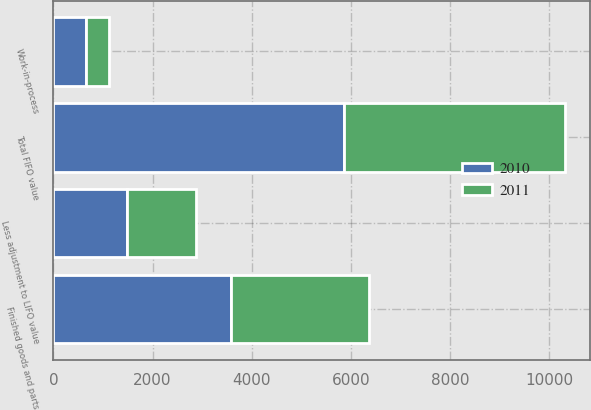Convert chart to OTSL. <chart><loc_0><loc_0><loc_500><loc_500><stacked_bar_chart><ecel><fcel>Work-in-process<fcel>Finished goods and parts<fcel>Total FIFO value<fcel>Less adjustment to LIFO value<nl><fcel>2010<fcel>647<fcel>3584<fcel>5857<fcel>1486<nl><fcel>2011<fcel>483<fcel>2777<fcel>4461<fcel>1398<nl></chart> 